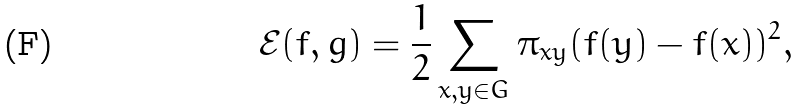<formula> <loc_0><loc_0><loc_500><loc_500>\mathcal { E } ( f , g ) = \frac { 1 } { 2 } \sum _ { x , y \in G } \pi _ { x y } ( f ( y ) - f ( x ) ) ^ { 2 } ,</formula> 